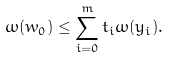<formula> <loc_0><loc_0><loc_500><loc_500>\omega ( w _ { 0 } ) \leq \sum _ { i = 0 } ^ { m } t _ { i } \omega ( y _ { i } ) .</formula> 